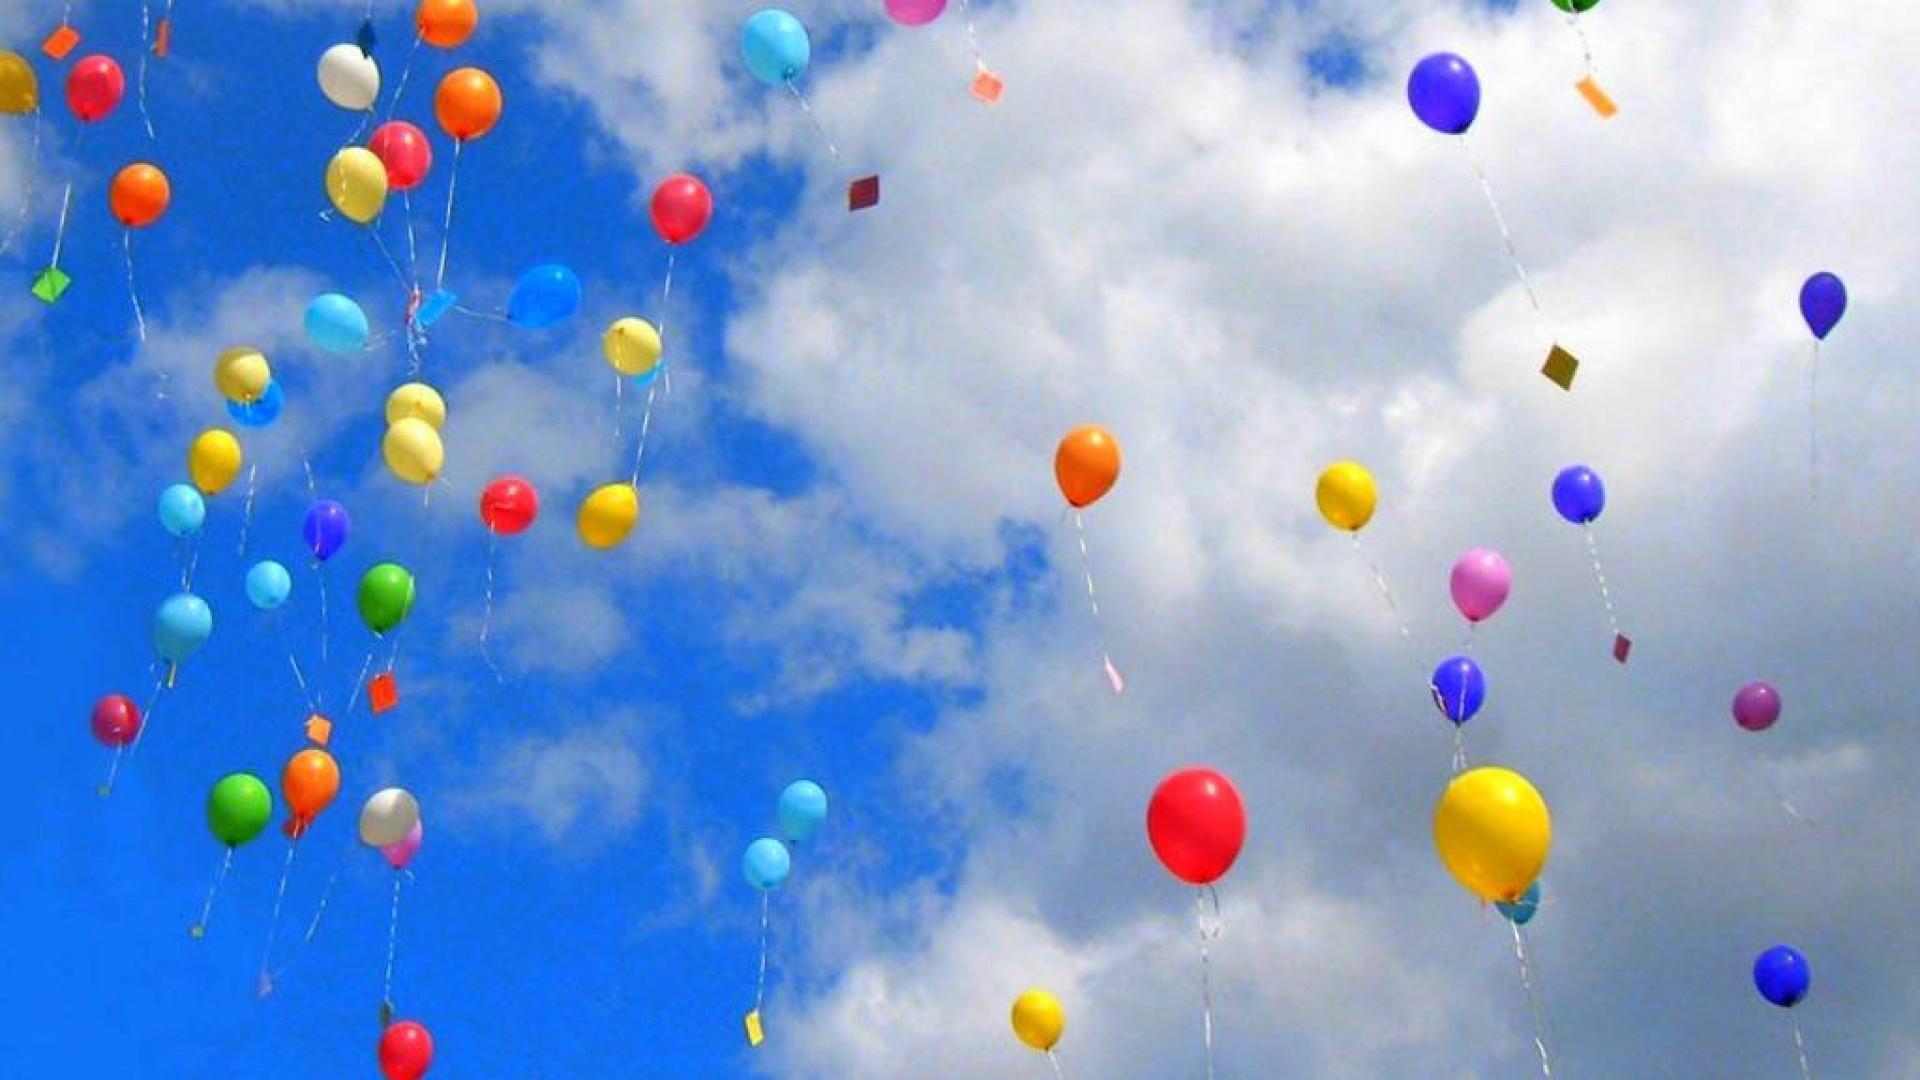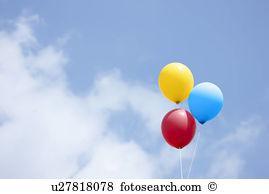The first image is the image on the left, the second image is the image on the right. For the images displayed, is the sentence "There are two other colored balloons with a yellow balloon in the right image." factually correct? Answer yes or no. Yes. The first image is the image on the left, the second image is the image on the right. For the images displayed, is the sentence "An image shows at least one person being lifted by means of balloon." factually correct? Answer yes or no. No. 